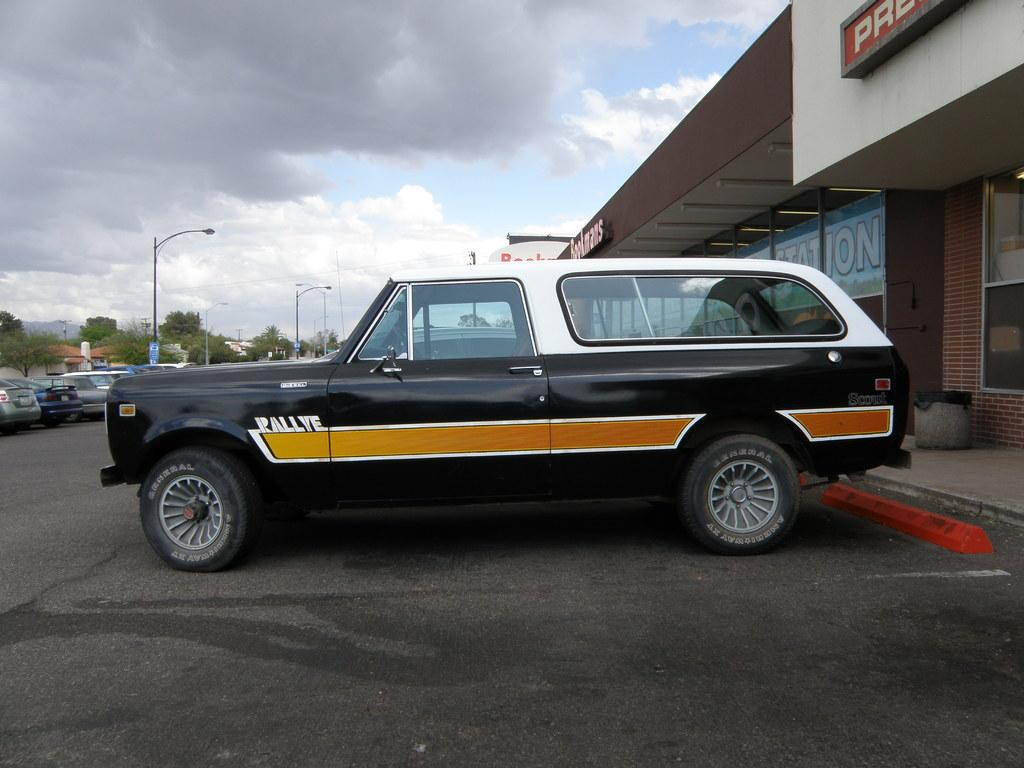What is the main subject in the middle of the image? There is a vehicle in the middle of the image. What is located at the bottom of the image? There is a road at the bottom of the image. What can be seen in the background of the image? There are buildings, posters, cars, street lights, trees, and the sky visible in the background of the image. What is the condition of the sky in the image? The sky is visible in the background of the image, and there are clouds present. What type of locket is hanging from the street light in the image? There is no locket present in the image; it features a vehicle, a road, and various elements in the background. 